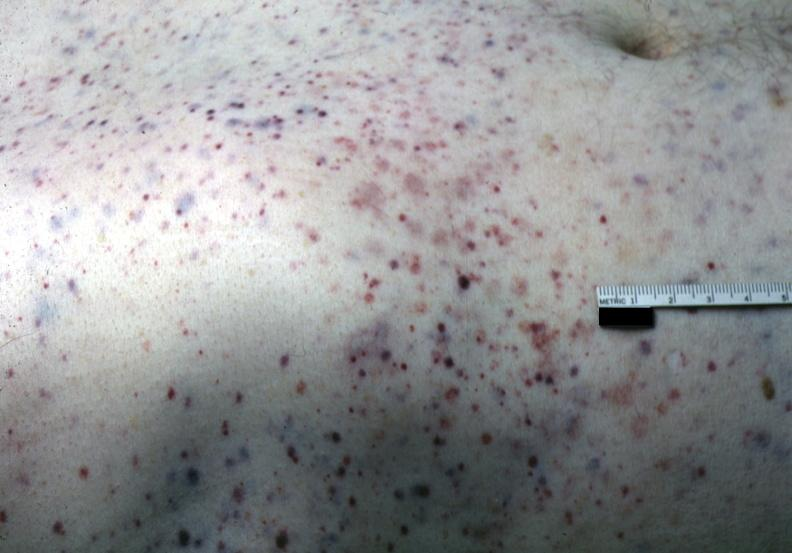what is present?
Answer the question using a single word or phrase. Petechial and purpuric hemorrhages 